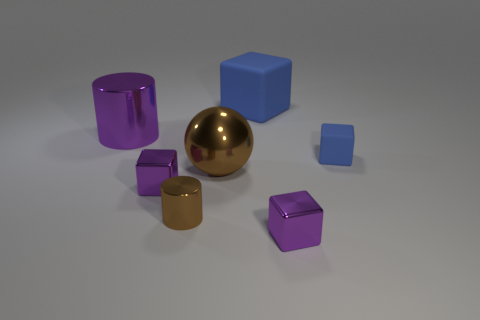Does the small purple block that is right of the large ball have the same material as the big purple thing that is in front of the large cube?
Ensure brevity in your answer.  Yes. There is a rubber object that is behind the big purple metallic cylinder; what shape is it?
Offer a very short reply. Cube. The other blue thing that is the same shape as the small blue object is what size?
Ensure brevity in your answer.  Large. Do the big rubber cube and the big sphere have the same color?
Provide a short and direct response. No. Are there any other things that are the same shape as the big blue thing?
Provide a succinct answer. Yes. There is a blue matte thing in front of the big matte object; is there a big metal cylinder that is behind it?
Your answer should be compact. Yes. There is a tiny matte thing that is the same shape as the big blue thing; what is its color?
Offer a very short reply. Blue. What number of cylinders have the same color as the big shiny sphere?
Your response must be concise. 1. The tiny metallic object that is on the left side of the metal cylinder that is in front of the purple metal object behind the brown shiny sphere is what color?
Make the answer very short. Purple. Do the ball and the small cylinder have the same material?
Provide a succinct answer. Yes. 